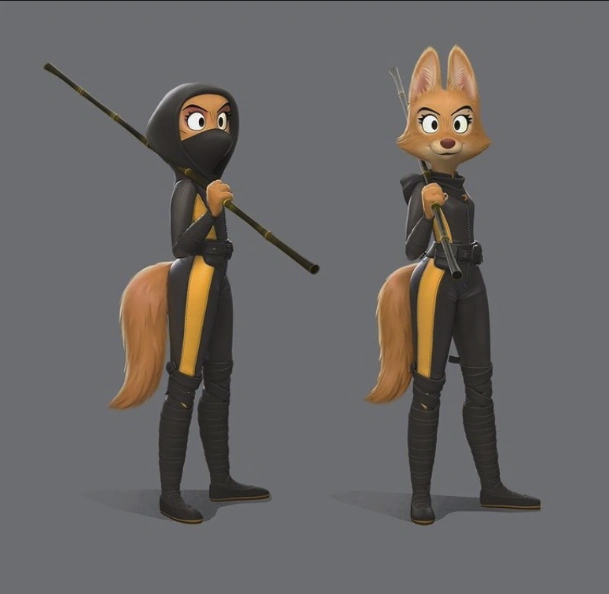A very detailed prompt to regenerate the image. A cartoon image of two anthropomorphic foxes in black and yellow ninja suits. They are both holding a staff in their hands. The fox on the left is standing in a more relaxed pose, while the fox on the right is standing in a more guarded stance. They both have determined looks on their faces. 